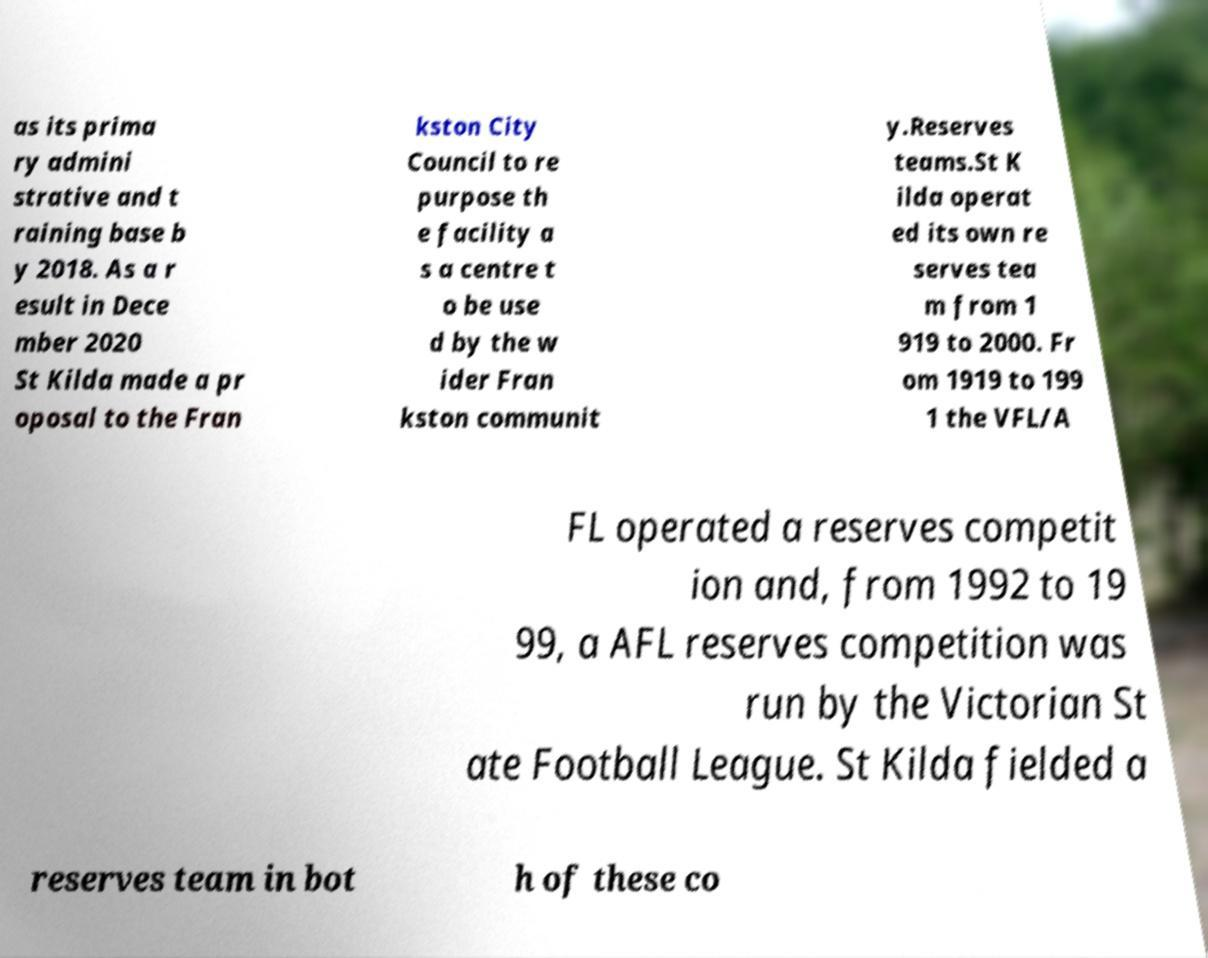What messages or text are displayed in this image? I need them in a readable, typed format. as its prima ry admini strative and t raining base b y 2018. As a r esult in Dece mber 2020 St Kilda made a pr oposal to the Fran kston City Council to re purpose th e facility a s a centre t o be use d by the w ider Fran kston communit y.Reserves teams.St K ilda operat ed its own re serves tea m from 1 919 to 2000. Fr om 1919 to 199 1 the VFL/A FL operated a reserves competit ion and, from 1992 to 19 99, a AFL reserves competition was run by the Victorian St ate Football League. St Kilda fielded a reserves team in bot h of these co 